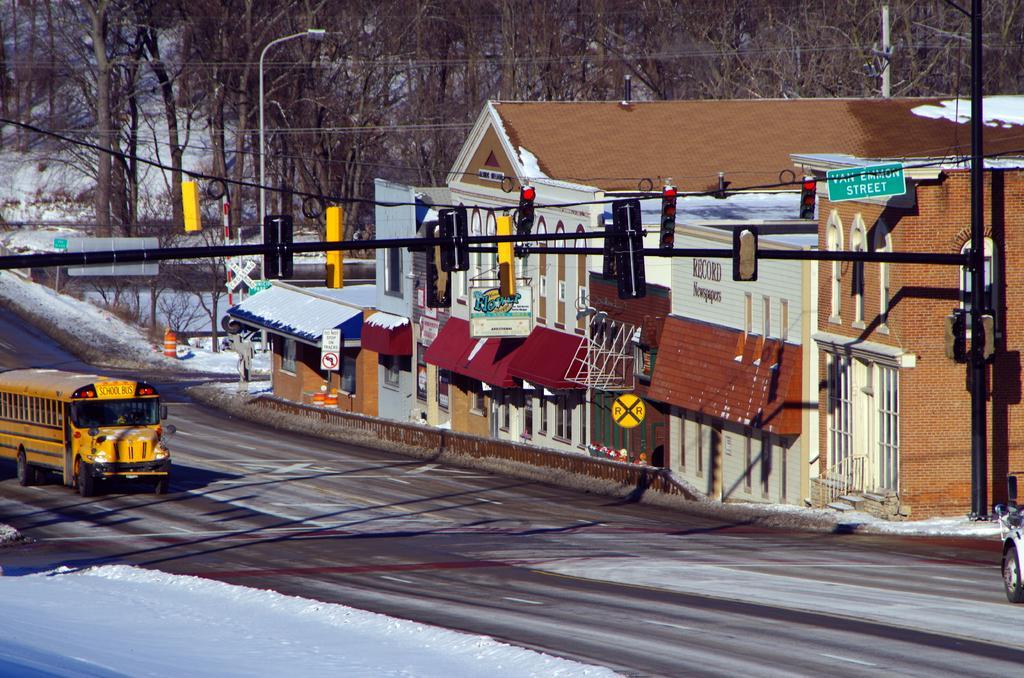Could you give a brief overview of what you see in this image? In this image I can see the vehicle on the road. The vehicle is in yellow color. To the side of the road I can see the light poles, boards and the house. In the background there are many trees and the snow. 